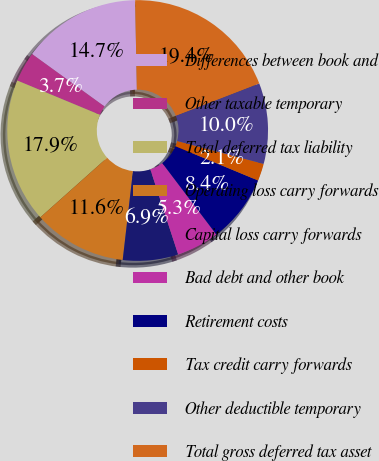Convert chart to OTSL. <chart><loc_0><loc_0><loc_500><loc_500><pie_chart><fcel>Differences between book and<fcel>Other taxable temporary<fcel>Total deferred tax liability<fcel>Operating loss carry forwards<fcel>Capital loss carry forwards<fcel>Bad debt and other book<fcel>Retirement costs<fcel>Tax credit carry forwards<fcel>Other deductible temporary<fcel>Total gross deferred tax asset<nl><fcel>14.72%<fcel>3.71%<fcel>17.86%<fcel>11.57%<fcel>6.86%<fcel>5.28%<fcel>8.43%<fcel>2.14%<fcel>10.0%<fcel>19.43%<nl></chart> 